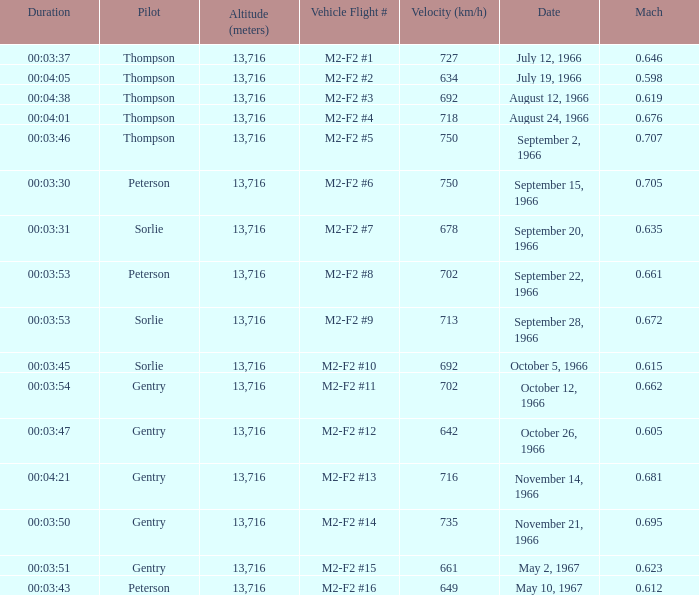What Vehicle Flight # has Pilot Peterson and Velocity (km/h) of 649? M2-F2 #16. 